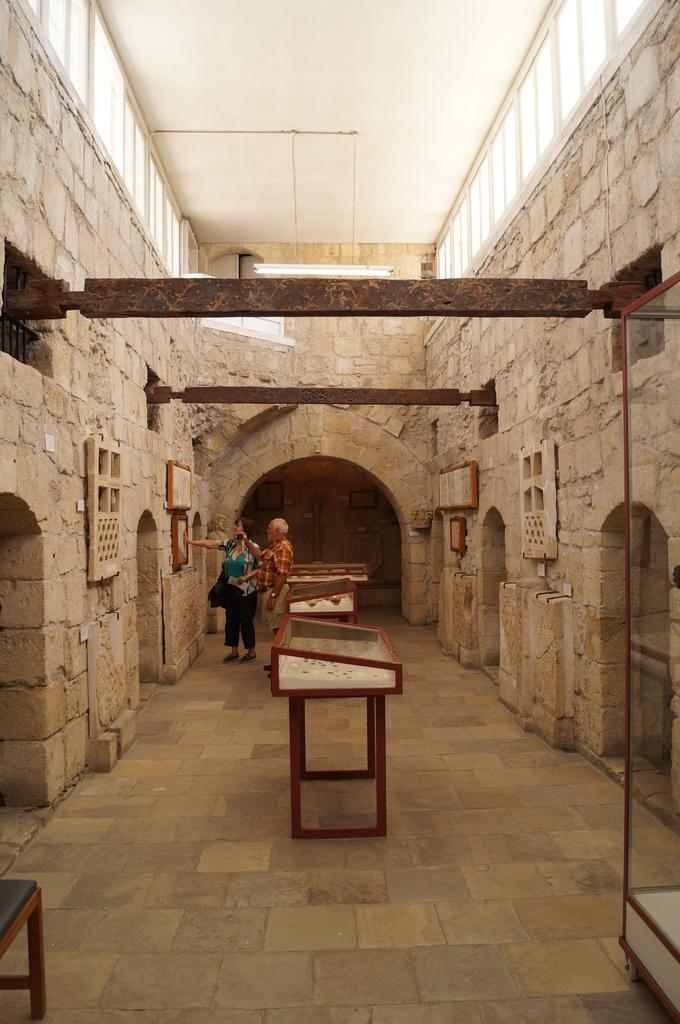What is the main object in the center of the image? There is a table in the center of the image. What can be seen in the background of the image? There are persons standing in the background of the image. What is located on the right side of the image? There is a glass stand on the right side of the image. What is on the left side of the image? There is an empty bench on the left side of the image. What type of basketball game is being played in the image? There is no basketball game present in the image. What is being cooked on the stove in the image? There is no stove present in the image. 